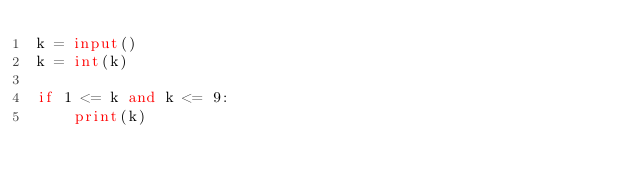<code> <loc_0><loc_0><loc_500><loc_500><_Python_>k = input()
k = int(k)

if 1 <= k and k <= 9:
    print(k)</code> 